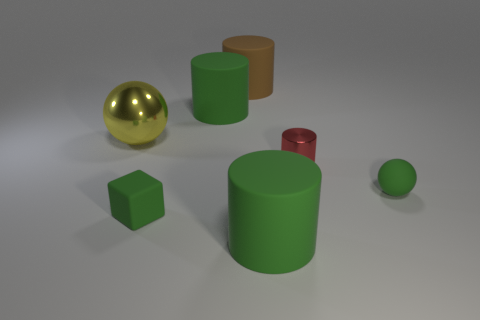Subtract all matte cylinders. How many cylinders are left? 1 Subtract all cyan balls. How many green cylinders are left? 2 Subtract 1 cylinders. How many cylinders are left? 3 Add 1 large yellow metal objects. How many objects exist? 8 Subtract all red cylinders. How many cylinders are left? 3 Subtract all cubes. How many objects are left? 6 Subtract all red cylinders. Subtract all gray balls. How many cylinders are left? 3 Subtract all green balls. Subtract all green balls. How many objects are left? 5 Add 1 tiny red objects. How many tiny red objects are left? 2 Add 4 large objects. How many large objects exist? 8 